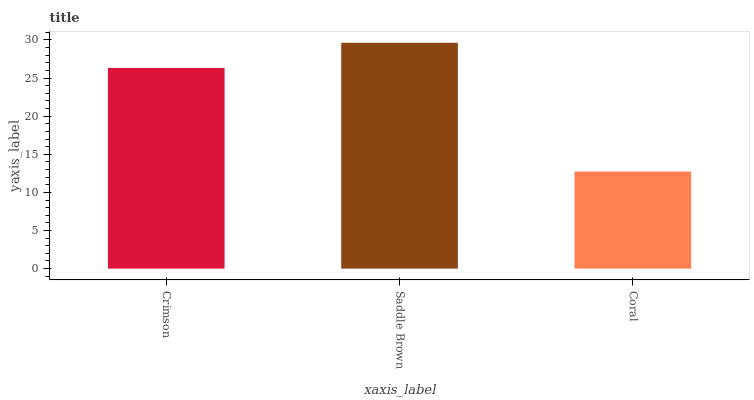Is Coral the minimum?
Answer yes or no. Yes. Is Saddle Brown the maximum?
Answer yes or no. Yes. Is Saddle Brown the minimum?
Answer yes or no. No. Is Coral the maximum?
Answer yes or no. No. Is Saddle Brown greater than Coral?
Answer yes or no. Yes. Is Coral less than Saddle Brown?
Answer yes or no. Yes. Is Coral greater than Saddle Brown?
Answer yes or no. No. Is Saddle Brown less than Coral?
Answer yes or no. No. Is Crimson the high median?
Answer yes or no. Yes. Is Crimson the low median?
Answer yes or no. Yes. Is Coral the high median?
Answer yes or no. No. Is Coral the low median?
Answer yes or no. No. 